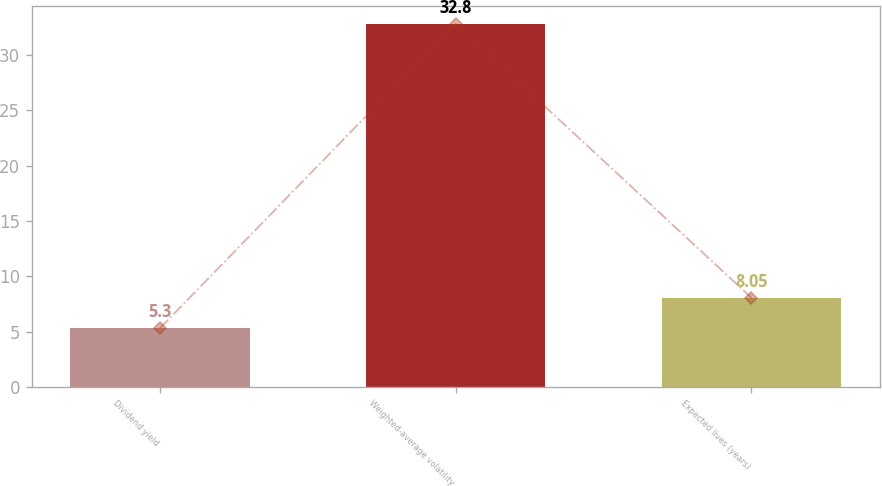<chart> <loc_0><loc_0><loc_500><loc_500><bar_chart><fcel>Dividend yield<fcel>Weighted-average volatility<fcel>Expected lives (years)<nl><fcel>5.3<fcel>32.8<fcel>8.05<nl></chart> 